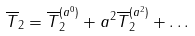Convert formula to latex. <formula><loc_0><loc_0><loc_500><loc_500>\overline { T } _ { 2 } = \overline { T } _ { 2 } ^ { ( a ^ { 0 } ) } + a ^ { 2 } \overline { T } _ { 2 } ^ { ( a ^ { 2 } ) } + \dots</formula> 